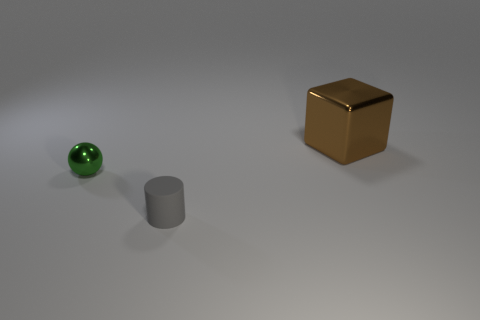There is a thing that is to the right of the small green ball and in front of the metal block; what is its color?
Provide a succinct answer. Gray. There is a object that is in front of the tiny green ball; does it have the same size as the thing that is to the left of the cylinder?
Your answer should be very brief. Yes. How many tiny cylinders have the same color as the small shiny sphere?
Your response must be concise. 0. How many large things are either green metallic objects or cyan metallic blocks?
Provide a short and direct response. 0. Are the thing that is right of the small gray thing and the ball made of the same material?
Your answer should be very brief. Yes. There is a metal thing that is to the left of the brown metallic object; what color is it?
Offer a terse response. Green. Are there any metallic objects of the same size as the matte object?
Provide a succinct answer. Yes. There is a gray cylinder that is the same size as the ball; what is its material?
Give a very brief answer. Rubber. There is a green ball; does it have the same size as the metallic object that is right of the small gray cylinder?
Your answer should be very brief. No. There is a small object that is to the right of the green sphere; what is its material?
Offer a very short reply. Rubber. 